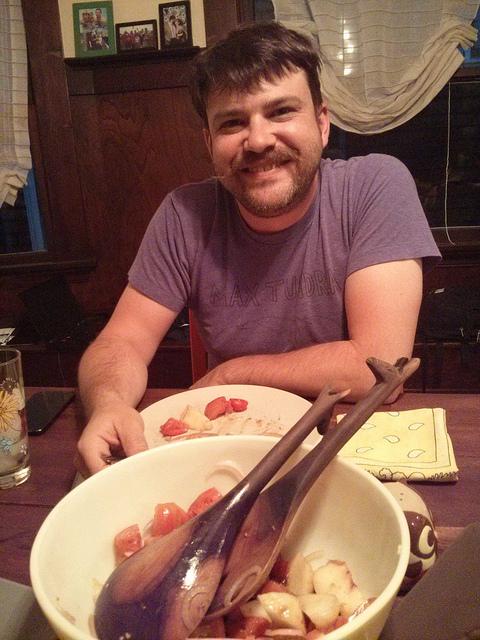Are the salad spoons metal?
Write a very short answer. No. What are the white objects in the bowl?
Be succinct. Potatoes. What kind of napkin is that in the picture?
Short answer required. Cloth. 